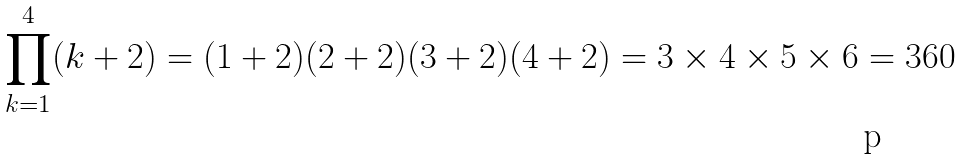<formula> <loc_0><loc_0><loc_500><loc_500>\prod _ { k = 1 } ^ { 4 } ( k + 2 ) = ( 1 + 2 ) ( 2 + 2 ) ( 3 + 2 ) ( 4 + 2 ) = 3 \times 4 \times 5 \times 6 = 3 6 0</formula> 